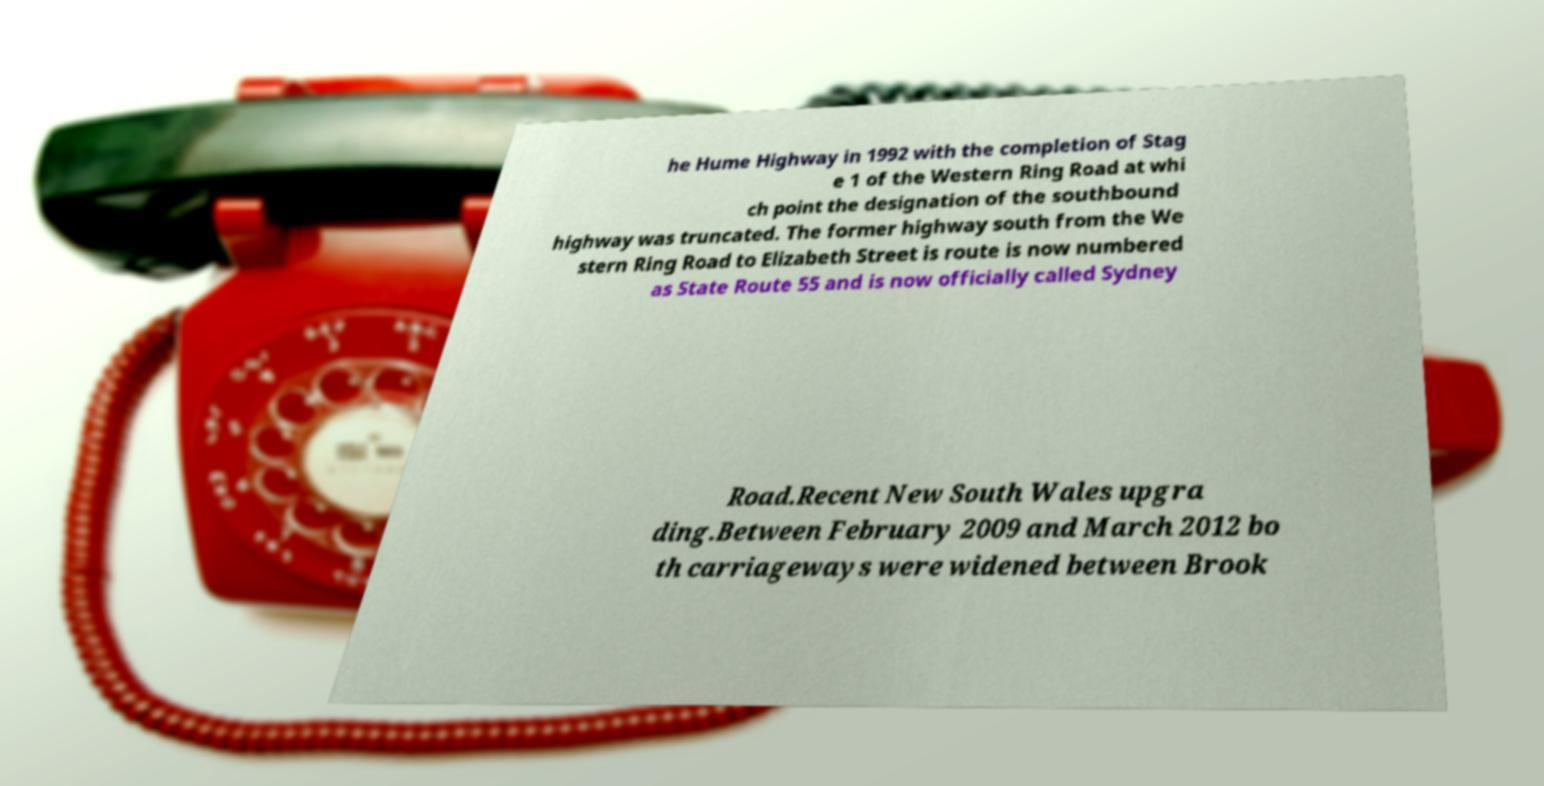Please identify and transcribe the text found in this image. he Hume Highway in 1992 with the completion of Stag e 1 of the Western Ring Road at whi ch point the designation of the southbound highway was truncated. The former highway south from the We stern Ring Road to Elizabeth Street is route is now numbered as State Route 55 and is now officially called Sydney Road.Recent New South Wales upgra ding.Between February 2009 and March 2012 bo th carriageways were widened between Brook 